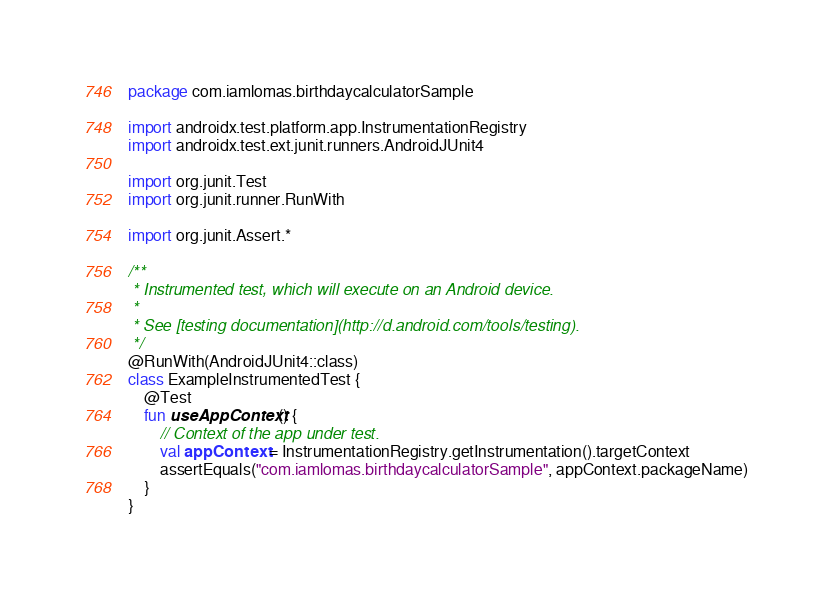<code> <loc_0><loc_0><loc_500><loc_500><_Kotlin_>package com.iamlomas.birthdaycalculatorSample

import androidx.test.platform.app.InstrumentationRegistry
import androidx.test.ext.junit.runners.AndroidJUnit4

import org.junit.Test
import org.junit.runner.RunWith

import org.junit.Assert.*

/**
 * Instrumented test, which will execute on an Android device.
 *
 * See [testing documentation](http://d.android.com/tools/testing).
 */
@RunWith(AndroidJUnit4::class)
class ExampleInstrumentedTest {
    @Test
    fun useAppContext() {
        // Context of the app under test.
        val appContext = InstrumentationRegistry.getInstrumentation().targetContext
        assertEquals("com.iamlomas.birthdaycalculatorSample", appContext.packageName)
    }
}</code> 